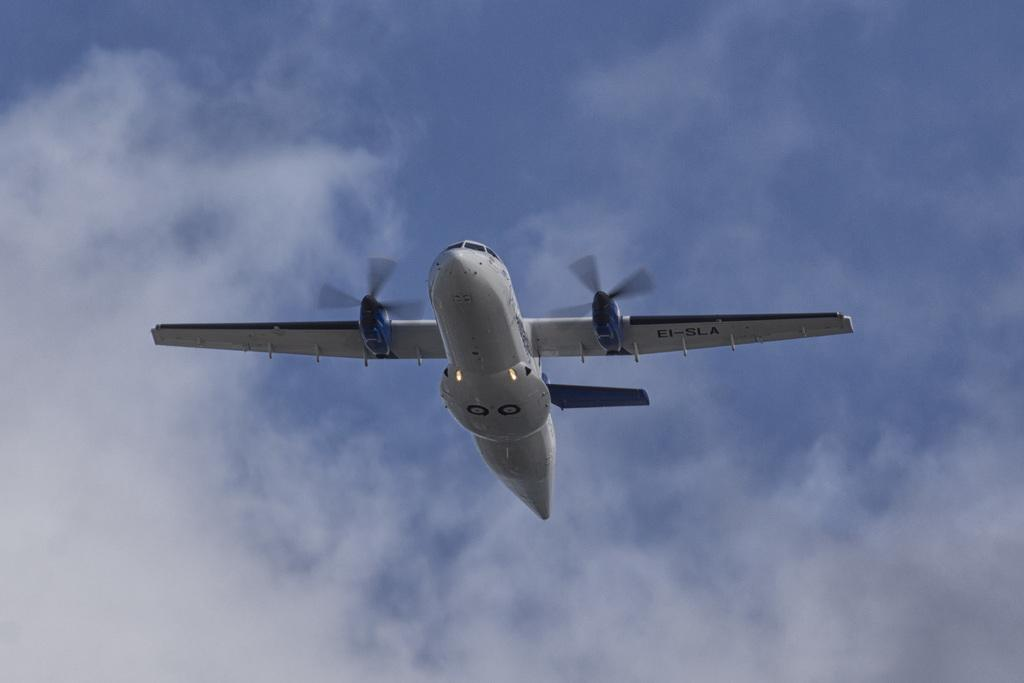What is the main subject of the picture? The main subject of the picture is an image that can be observed in the center. Can you describe the location of the main subject? The image is in the center of the picture. What is the aircraft doing in the image? The aircraft is in the air. How would you describe the weather based on the image? The sky is sunny, suggesting good weather. Can you see any feathers floating around the aircraft in the image? There are no feathers visible in the image; the focus is on the aircraft in the air. Is there a pail being used to collect water in the image? There is no pail or water collection activity depicted in the image. 